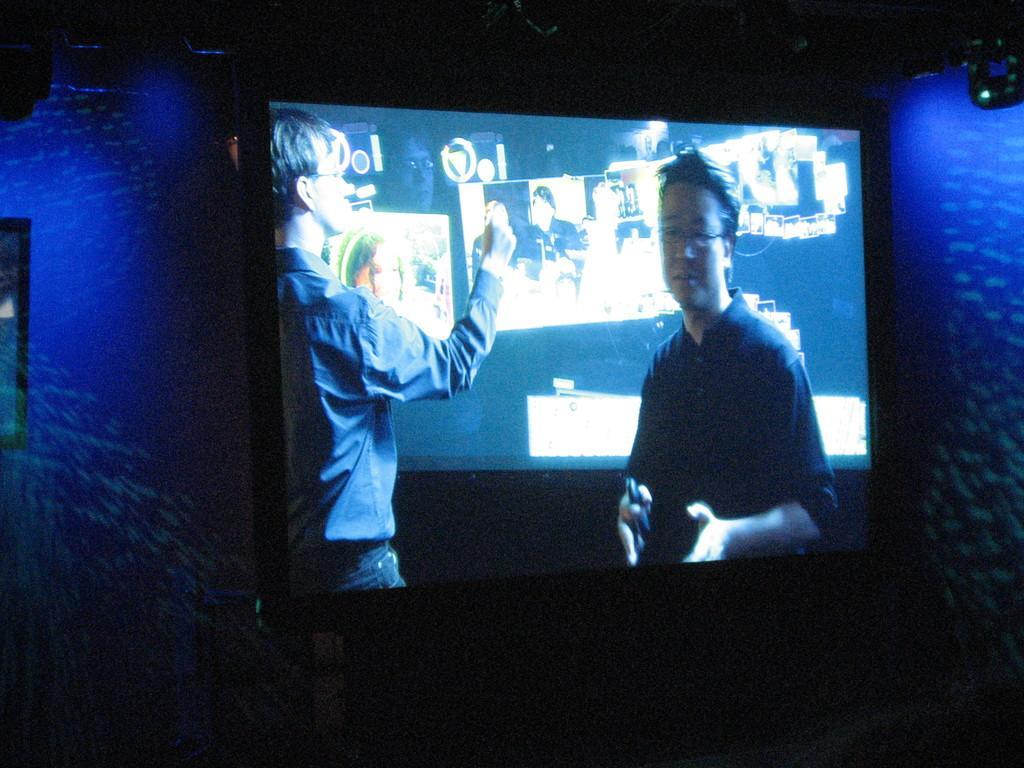How would you summarize this image in a sentence or two? In the center of the picture there is a television. On the right there is a light and wall painted blue. On the left there is a wall painted blue. 